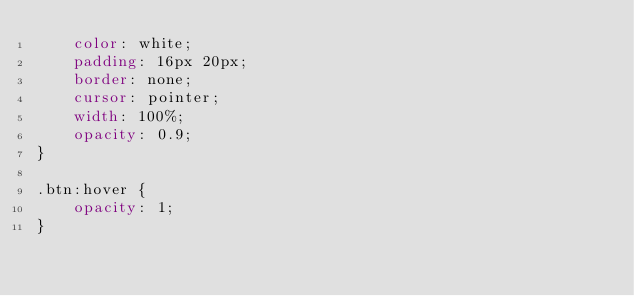<code> <loc_0><loc_0><loc_500><loc_500><_CSS_>    color: white;
    padding: 16px 20px;
    border: none;
    cursor: pointer;
    width: 100%;
    opacity: 0.9;
}

.btn:hover {
    opacity: 1;
}</code> 